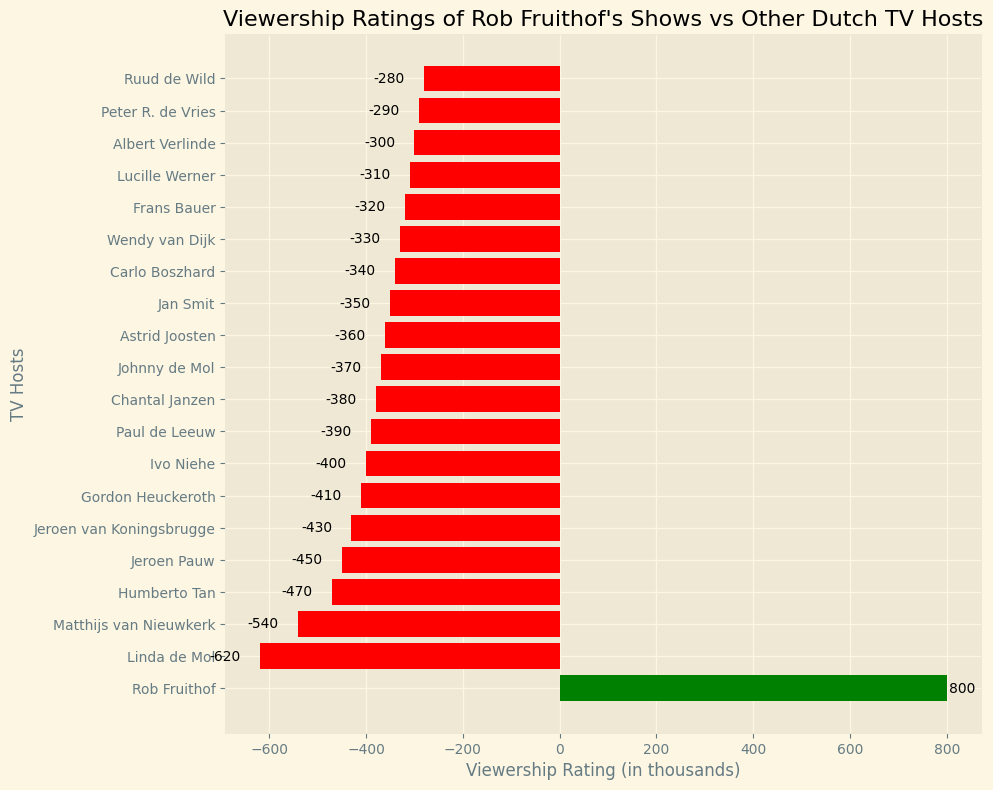Which TV host has the highest viewership rating? The highest bar in the chart is green, representing Rob Fruithof with a rating of 800 thousand, significantly higher than all the other hosts.
Answer: Rob Fruithof How many TV hosts have a negative viewership rating? The bars colored in red represent negative ratings. Counting these red bars in the chart, we observe that there are 19 such hosts.
Answer: 19 What is the difference in viewership rating between Rob Fruithof and Linda de Mol? Rob Fruithof has a rating of 800 thousand, and Linda de Mol has a rating of -620 thousand. The difference is 800 - (-620), which equals 1420 thousand.
Answer: 1420 Which TV hosts have a viewership rating of more than -400 thousand but less than -300 thousand? By observing the length and position of the bars, we see that Gordon Heuckeroth (-410), and Ivo Niehe (-400) do not fit the range. The remaining bars within this range represent Astrid Joosten (-360), Jan Smit (-350), Carlo Boszhard (-340), Wendy van Dijk (-330), Frans Bauer (-320), and Lucille Werner (-310).
Answer: Astrid Joosten, Jan Smit, Carlo Boszhard, Wendy van Dijk, Frans Bauer, Lucille Werner What is the sum of the viewership ratings of the bottom three hosts? The bottom three hosts are Ruud de Wild (-280), Peter R. de Vries (-290), and Albert Verlinde (-300). Summing them up gives -280 + (-290) + (-300) = -870.
Answer: -870 What is the average viewership rating for the TV hosts represented in the chart? There are 20 hosts in total. Sum of the ratings is 800 + (-620) + (-540) + (-470) + (-450) + (-430) + (-410) + (-400) + (-390) + (-380) + (-370) + (-360) + (-350) + (-340) + (-330) + (-320) + (-310) + (-300) + (-290) + (-280) = -6840. The average rating is -6840 / 20 = -342.
Answer: -342 Is there any TV host with an equal viewership rating to Paul de Leeuw? Checking the chart, Paul de Leeuw has a rating of -390 thousand. No other bars align with this value exactly.
Answer: No Who has a higher viewership rating: Jeroen Pauw or Johnny de Mol? Jeroen Pauw has a rating of -450 thousand, which is lower than Johnny de Mol's rating of -370 thousand.
Answer: Johnny de Mol What percentage of the TV hosts have a rating below the average viewership rating? The average rating is -342. Hosts with ratings below this are Ruud de Wild, Peter R. de Vries, Albert Verlinde, Lucille Werner, Frans Bauer, Wendy van Dijk, Carlo Boszhard, Jan Smit, Astrid Joosten, Johnny de Mol, Chantal Janzen, Paul de Leeuw, Ivo Niehe, Gordon Heuckeroth, and Jeroen van Koningsbrugge, thus 15 out of 20 hosts. The percentage is (15/20) * 100 = 75%.
Answer: 75% 